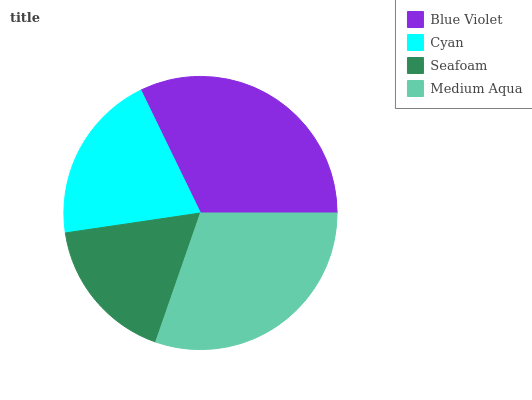Is Seafoam the minimum?
Answer yes or no. Yes. Is Blue Violet the maximum?
Answer yes or no. Yes. Is Cyan the minimum?
Answer yes or no. No. Is Cyan the maximum?
Answer yes or no. No. Is Blue Violet greater than Cyan?
Answer yes or no. Yes. Is Cyan less than Blue Violet?
Answer yes or no. Yes. Is Cyan greater than Blue Violet?
Answer yes or no. No. Is Blue Violet less than Cyan?
Answer yes or no. No. Is Medium Aqua the high median?
Answer yes or no. Yes. Is Cyan the low median?
Answer yes or no. Yes. Is Cyan the high median?
Answer yes or no. No. Is Blue Violet the low median?
Answer yes or no. No. 